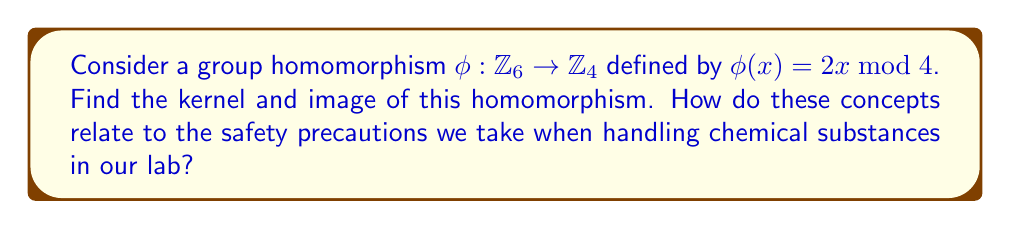Help me with this question. Let's approach this step-by-step:

1) First, let's recall what a kernel and image are:
   - The kernel of a homomorphism $\phi$ is the set of all elements that map to the identity element in the codomain.
   - The image of a homomorphism $\phi$ is the set of all elements in the codomain that are mapped to by at least one element in the domain.

2) To find the kernel, we need to determine which elements of $\mathbb{Z}_6$ map to 0 in $\mathbb{Z}_4$:
   
   $\phi(0) = 2(0) \bmod 4 = 0$
   $\phi(1) = 2(1) \bmod 4 = 2$
   $\phi(2) = 2(2) \bmod 4 = 0$
   $\phi(3) = 2(3) \bmod 4 = 2$
   $\phi(4) = 2(4) \bmod 4 = 0$
   $\phi(5) = 2(5) \bmod 4 = 2$

   The elements that map to 0 are 0, 2, and 4.

3) To find the image, we look at all the distinct values in the codomain that are reached:
   From the calculations above, we see that the only values reached are 0 and 2.

4) Relating to lab safety:
   - The kernel represents elements that "disappear" under the homomorphism, similar to how certain safety precautions (like wearing gloves) can "neutralize" potential hazards.
   - The image represents the "effect" of the homomorphism, similar to how our safety measures have a tangible impact on lab conditions.
   - Just as the homomorphism preserves the group structure, our safety measures preserve the integrity of our experiments and the well-being of the students.
Answer: Kernel: $\ker(\phi) = \{0, 2, 4\}$
Image: $\text{Im}(\phi) = \{0, 2\}$ 